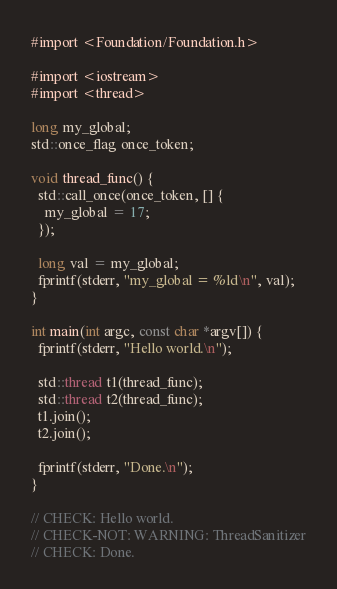Convert code to text. <code><loc_0><loc_0><loc_500><loc_500><_ObjectiveC_>
#import <Foundation/Foundation.h>

#import <iostream>
#import <thread>

long my_global;
std::once_flag once_token;

void thread_func() {
  std::call_once(once_token, [] {
    my_global = 17;
  });

  long val = my_global;
  fprintf(stderr, "my_global = %ld\n", val);
}

int main(int argc, const char *argv[]) {
  fprintf(stderr, "Hello world.\n");

  std::thread t1(thread_func);
  std::thread t2(thread_func);
  t1.join();
  t2.join();

  fprintf(stderr, "Done.\n");
}

// CHECK: Hello world.
// CHECK-NOT: WARNING: ThreadSanitizer
// CHECK: Done.
</code> 